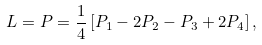<formula> <loc_0><loc_0><loc_500><loc_500>L = P = \frac { 1 } { 4 } \left [ P _ { 1 } - 2 P _ { 2 } - P _ { 3 } + 2 P _ { 4 } \right ] ,</formula> 